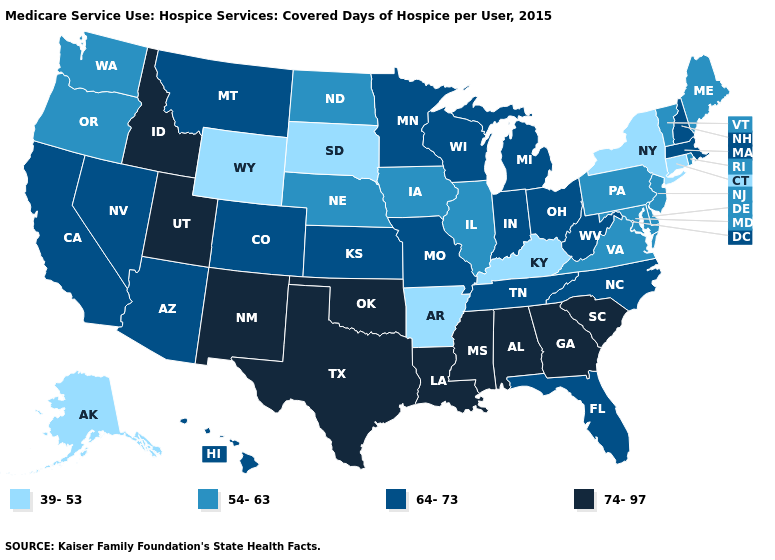Is the legend a continuous bar?
Short answer required. No. Does the first symbol in the legend represent the smallest category?
Quick response, please. Yes. What is the value of Massachusetts?
Concise answer only. 64-73. What is the value of Illinois?
Be succinct. 54-63. Among the states that border North Carolina , which have the lowest value?
Answer briefly. Virginia. What is the value of Montana?
Quick response, please. 64-73. Which states hav the highest value in the MidWest?
Write a very short answer. Indiana, Kansas, Michigan, Minnesota, Missouri, Ohio, Wisconsin. Does Idaho have a higher value than Arizona?
Concise answer only. Yes. What is the lowest value in the MidWest?
Short answer required. 39-53. What is the value of Arizona?
Keep it brief. 64-73. What is the highest value in the West ?
Keep it brief. 74-97. What is the value of Iowa?
Be succinct. 54-63. Among the states that border Missouri , which have the lowest value?
Short answer required. Arkansas, Kentucky. Among the states that border Illinois , does Wisconsin have the highest value?
Short answer required. Yes. Does Wyoming have a lower value than New York?
Write a very short answer. No. 